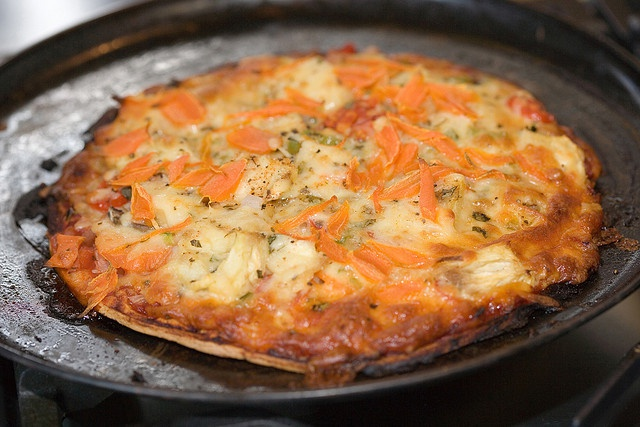Describe the objects in this image and their specific colors. I can see a pizza in darkgray, tan, brown, orange, and red tones in this image. 